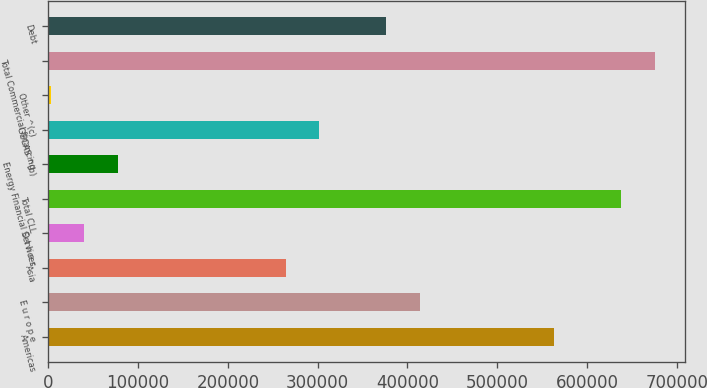<chart> <loc_0><loc_0><loc_500><loc_500><bar_chart><fcel>Americas<fcel>E u r o p e<fcel>Asia<fcel>O t h e r<fcel>Total CLL<fcel>Energy Financial Services<fcel>GECAS ^(b)<fcel>Other ^(c)<fcel>Total Commercial financing<fcel>Debt<nl><fcel>563720<fcel>414092<fcel>264464<fcel>40021.1<fcel>638535<fcel>77428.2<fcel>301871<fcel>2614<fcel>675942<fcel>376685<nl></chart> 